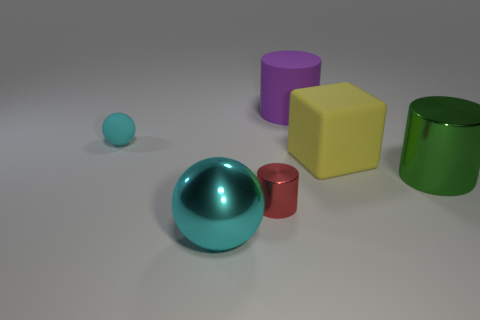There is a yellow cube in front of the cyan matte object; what size is it?
Your answer should be very brief. Large. What number of other purple things have the same shape as the small metal object?
Offer a terse response. 1. There is a big purple thing that is made of the same material as the large yellow object; what is its shape?
Your response must be concise. Cylinder. What number of cyan objects are metal spheres or big cubes?
Your response must be concise. 1. There is a large yellow cube; are there any small cyan objects on the right side of it?
Make the answer very short. No. Do the cyan object behind the large yellow rubber block and the metal object behind the tiny red cylinder have the same shape?
Your answer should be compact. No. What material is the purple object that is the same shape as the large green metallic object?
Your answer should be compact. Rubber. What number of cubes are either red shiny objects or large purple things?
Provide a succinct answer. 0. How many cyan balls have the same material as the small red object?
Your answer should be compact. 1. Does the cylinder in front of the large green metal cylinder have the same material as the tiny object behind the red cylinder?
Give a very brief answer. No. 